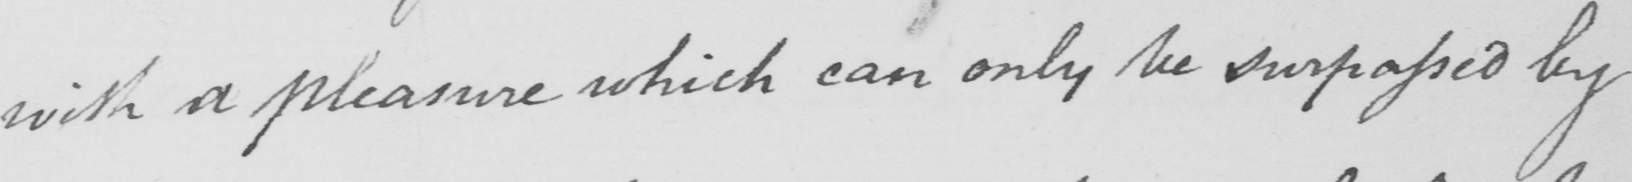Can you read and transcribe this handwriting? with a pleasure which can only be surpassed by 